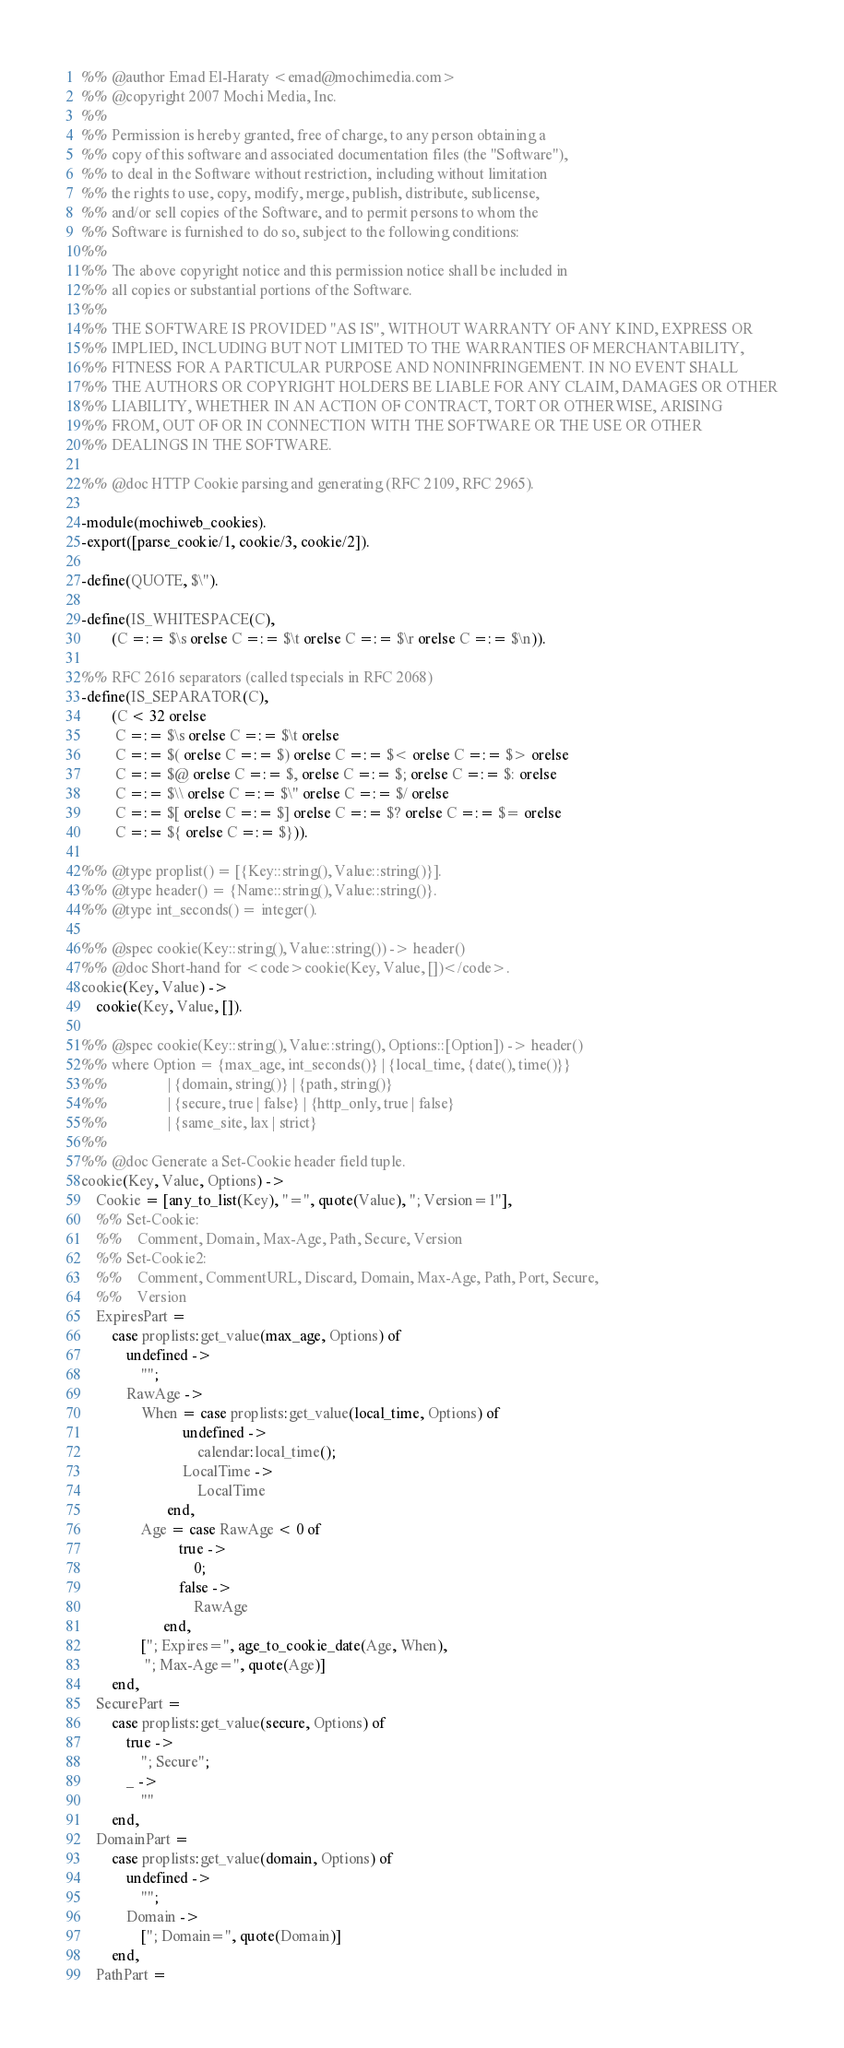Convert code to text. <code><loc_0><loc_0><loc_500><loc_500><_Erlang_>%% @author Emad El-Haraty <emad@mochimedia.com>
%% @copyright 2007 Mochi Media, Inc.
%%
%% Permission is hereby granted, free of charge, to any person obtaining a
%% copy of this software and associated documentation files (the "Software"),
%% to deal in the Software without restriction, including without limitation
%% the rights to use, copy, modify, merge, publish, distribute, sublicense,
%% and/or sell copies of the Software, and to permit persons to whom the
%% Software is furnished to do so, subject to the following conditions:
%%
%% The above copyright notice and this permission notice shall be included in
%% all copies or substantial portions of the Software.
%%
%% THE SOFTWARE IS PROVIDED "AS IS", WITHOUT WARRANTY OF ANY KIND, EXPRESS OR
%% IMPLIED, INCLUDING BUT NOT LIMITED TO THE WARRANTIES OF MERCHANTABILITY,
%% FITNESS FOR A PARTICULAR PURPOSE AND NONINFRINGEMENT. IN NO EVENT SHALL
%% THE AUTHORS OR COPYRIGHT HOLDERS BE LIABLE FOR ANY CLAIM, DAMAGES OR OTHER
%% LIABILITY, WHETHER IN AN ACTION OF CONTRACT, TORT OR OTHERWISE, ARISING
%% FROM, OUT OF OR IN CONNECTION WITH THE SOFTWARE OR THE USE OR OTHER
%% DEALINGS IN THE SOFTWARE.

%% @doc HTTP Cookie parsing and generating (RFC 2109, RFC 2965).

-module(mochiweb_cookies).
-export([parse_cookie/1, cookie/3, cookie/2]).

-define(QUOTE, $\").

-define(IS_WHITESPACE(C),
        (C =:= $\s orelse C =:= $\t orelse C =:= $\r orelse C =:= $\n)).

%% RFC 2616 separators (called tspecials in RFC 2068)
-define(IS_SEPARATOR(C),
        (C < 32 orelse
         C =:= $\s orelse C =:= $\t orelse
         C =:= $( orelse C =:= $) orelse C =:= $< orelse C =:= $> orelse
         C =:= $@ orelse C =:= $, orelse C =:= $; orelse C =:= $: orelse
         C =:= $\\ orelse C =:= $\" orelse C =:= $/ orelse
         C =:= $[ orelse C =:= $] orelse C =:= $? orelse C =:= $= orelse
         C =:= ${ orelse C =:= $})).

%% @type proplist() = [{Key::string(), Value::string()}].
%% @type header() = {Name::string(), Value::string()}.
%% @type int_seconds() = integer().

%% @spec cookie(Key::string(), Value::string()) -> header()
%% @doc Short-hand for <code>cookie(Key, Value, [])</code>.
cookie(Key, Value) ->
    cookie(Key, Value, []).

%% @spec cookie(Key::string(), Value::string(), Options::[Option]) -> header()
%% where Option = {max_age, int_seconds()} | {local_time, {date(), time()}}
%%                | {domain, string()} | {path, string()}
%%                | {secure, true | false} | {http_only, true | false}
%%                | {same_site, lax | strict}
%%
%% @doc Generate a Set-Cookie header field tuple.
cookie(Key, Value, Options) ->
    Cookie = [any_to_list(Key), "=", quote(Value), "; Version=1"],
    %% Set-Cookie:
    %%    Comment, Domain, Max-Age, Path, Secure, Version
    %% Set-Cookie2:
    %%    Comment, CommentURL, Discard, Domain, Max-Age, Path, Port, Secure,
    %%    Version
    ExpiresPart =
        case proplists:get_value(max_age, Options) of
            undefined ->
                "";
            RawAge ->
                When = case proplists:get_value(local_time, Options) of
                           undefined ->
                               calendar:local_time();
                           LocalTime ->
                               LocalTime
                       end,
                Age = case RawAge < 0 of
                          true ->
                              0;
                          false ->
                              RawAge
                      end,
                ["; Expires=", age_to_cookie_date(Age, When),
                 "; Max-Age=", quote(Age)]
        end,
    SecurePart =
        case proplists:get_value(secure, Options) of
            true ->
                "; Secure";
            _ ->
                ""
        end,
    DomainPart =
        case proplists:get_value(domain, Options) of
            undefined ->
                "";
            Domain ->
                ["; Domain=", quote(Domain)]
        end,
    PathPart =</code> 